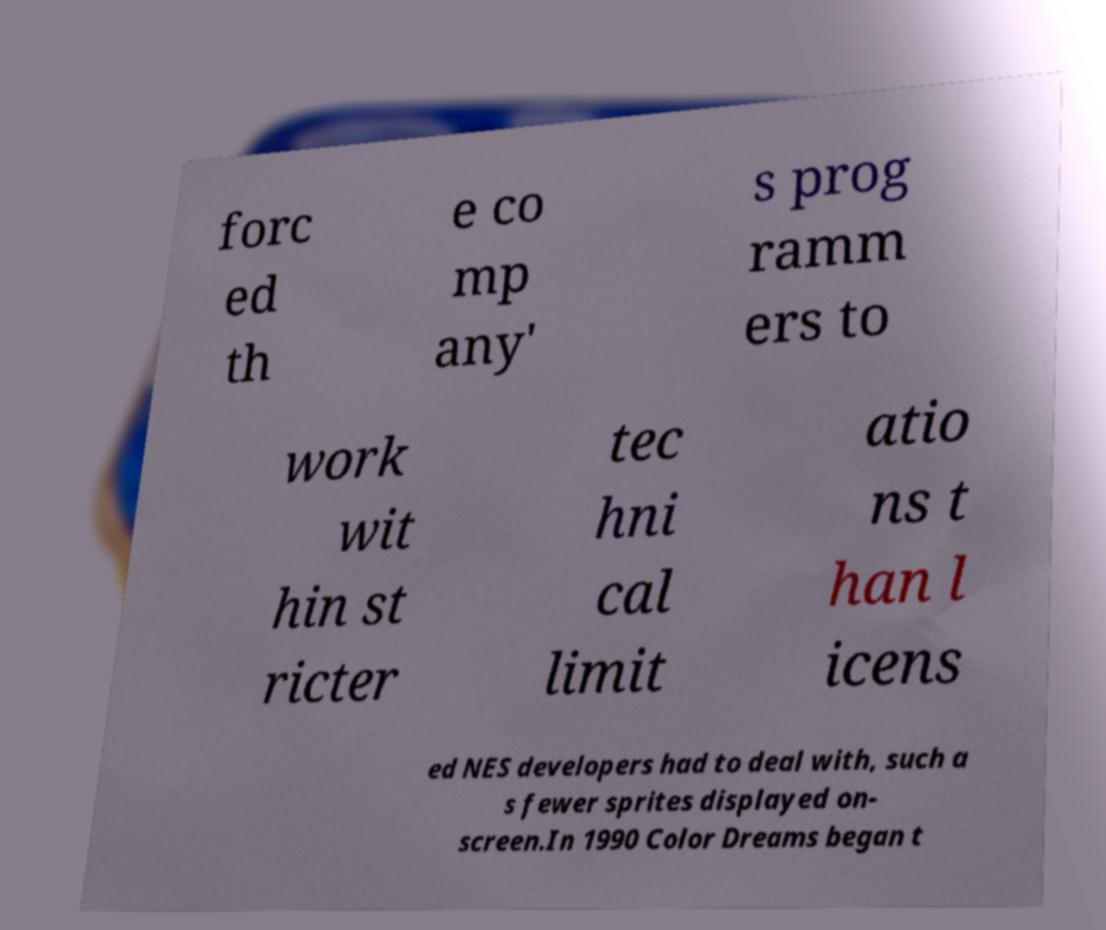Can you accurately transcribe the text from the provided image for me? forc ed th e co mp any' s prog ramm ers to work wit hin st ricter tec hni cal limit atio ns t han l icens ed NES developers had to deal with, such a s fewer sprites displayed on- screen.In 1990 Color Dreams began t 